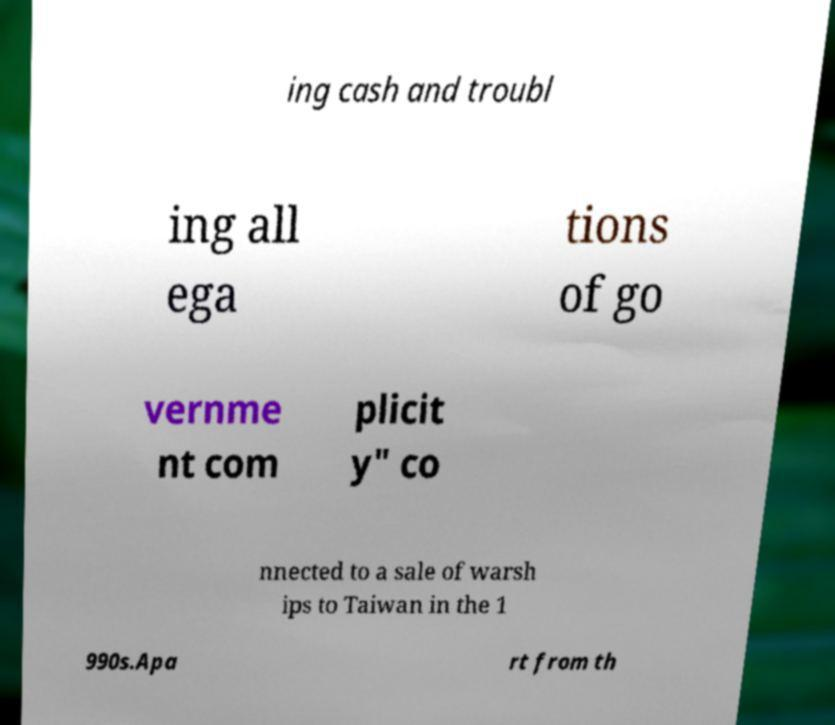I need the written content from this picture converted into text. Can you do that? ing cash and troubl ing all ega tions of go vernme nt com plicit y" co nnected to a sale of warsh ips to Taiwan in the 1 990s.Apa rt from th 